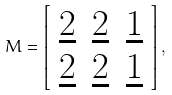<formula> <loc_0><loc_0><loc_500><loc_500>M = \left [ \begin{array} { c c c } { \underline { 2 } } & { \underline { 2 } } & { \underline { 1 } } \\ { \underline { 2 } } & { \underline { 2 } } & { \underline { 1 } } \end{array} \right ] ,</formula> 